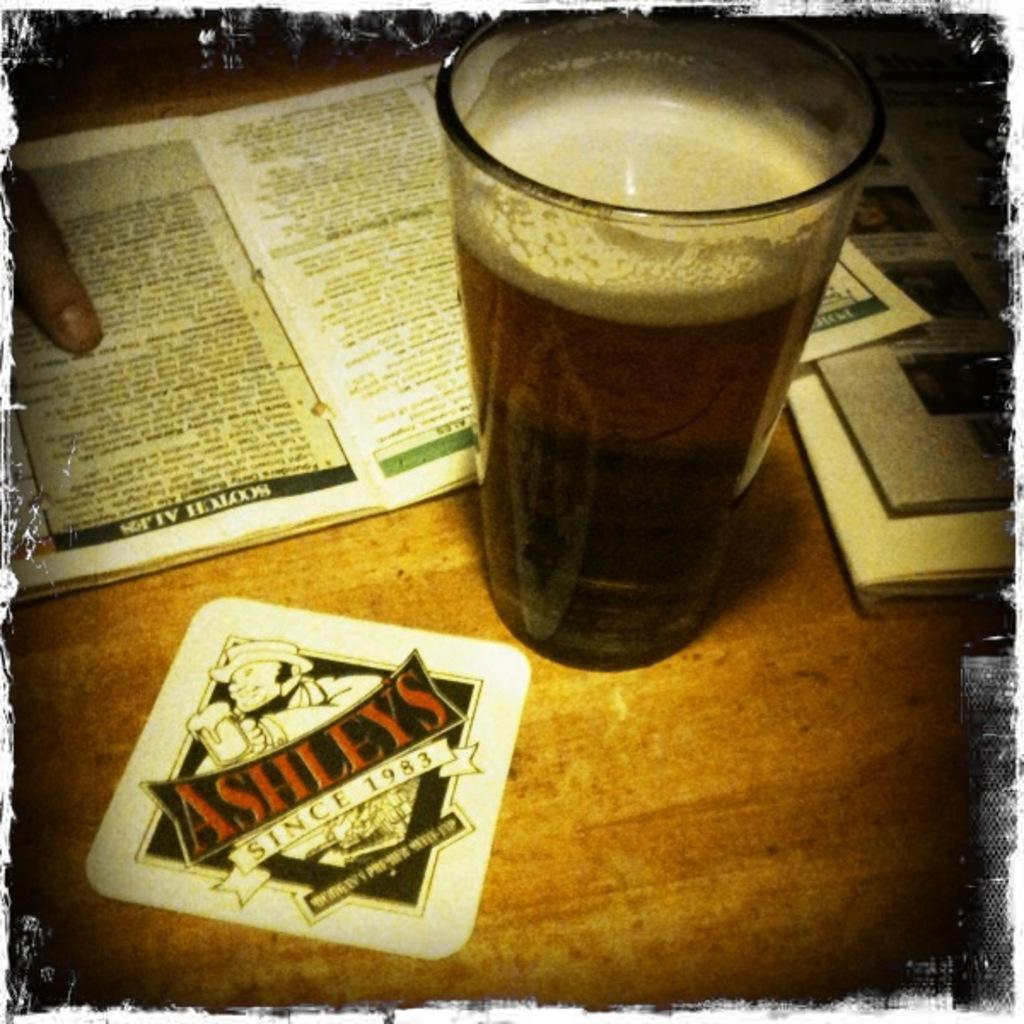<image>
Write a terse but informative summary of the picture. A beer next to a coaster that has the name Ashley's on it. 